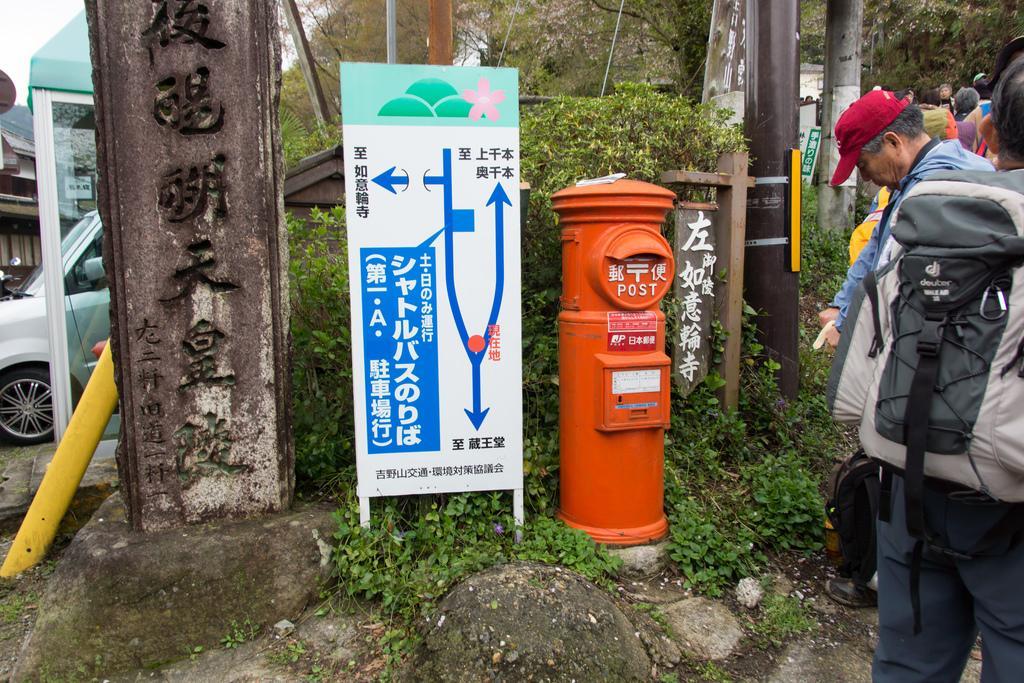In one or two sentences, can you explain what this image depicts? In this image I can see few persons standing. The person in front wearing bag which is in black and gray color, in front I can see a pole in orange color, board in white color. Background I can see a vehicle, trees in green color and sky in white color. 